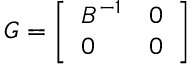Convert formula to latex. <formula><loc_0><loc_0><loc_500><loc_500>G = { \left [ \begin{array} { l l } { B ^ { - 1 } } & { 0 } \\ { 0 } & { 0 } \end{array} \right ] }</formula> 